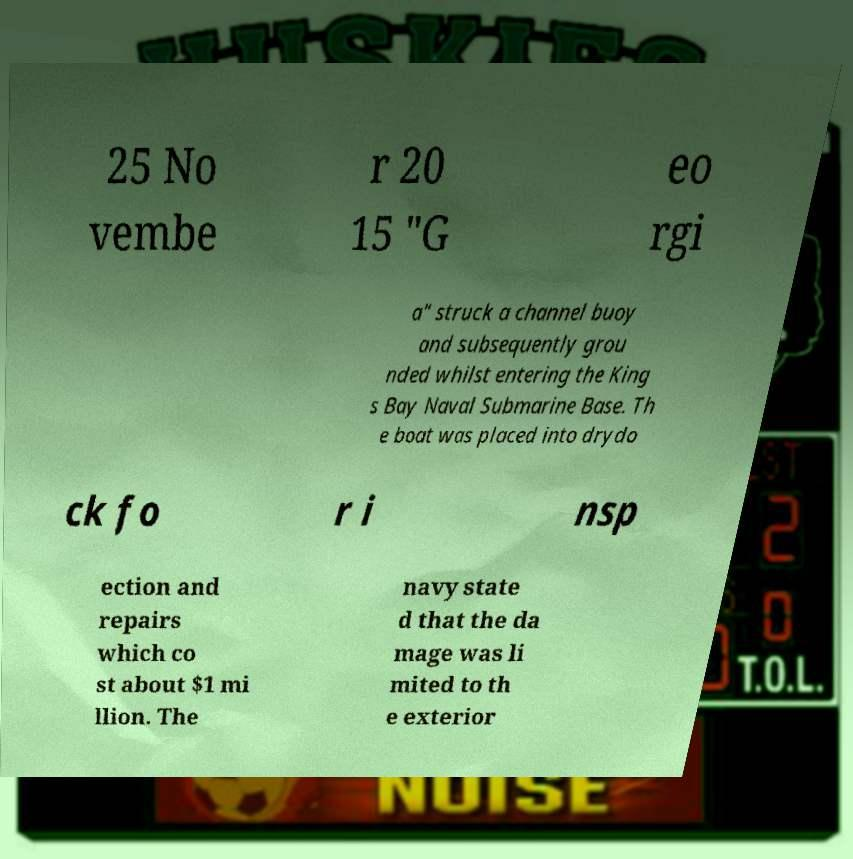Can you read and provide the text displayed in the image?This photo seems to have some interesting text. Can you extract and type it out for me? 25 No vembe r 20 15 "G eo rgi a" struck a channel buoy and subsequently grou nded whilst entering the King s Bay Naval Submarine Base. Th e boat was placed into drydo ck fo r i nsp ection and repairs which co st about $1 mi llion. The navy state d that the da mage was li mited to th e exterior 